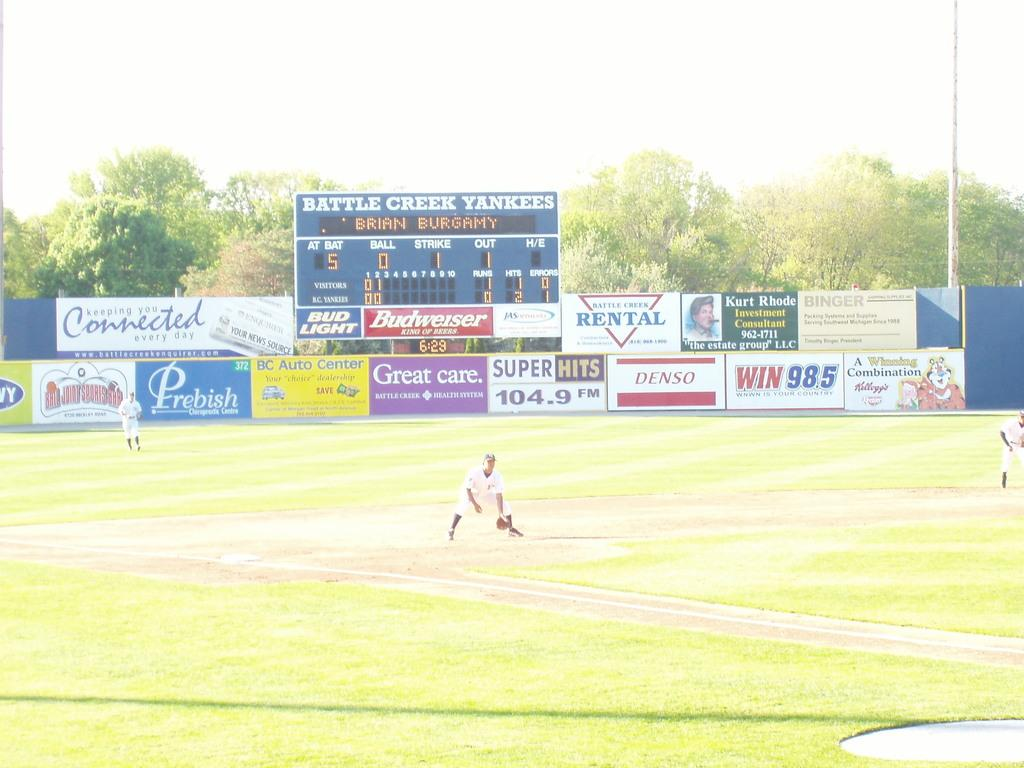<image>
Give a short and clear explanation of the subsequent image. The team playing here has the name of Battle Creek Yankees 